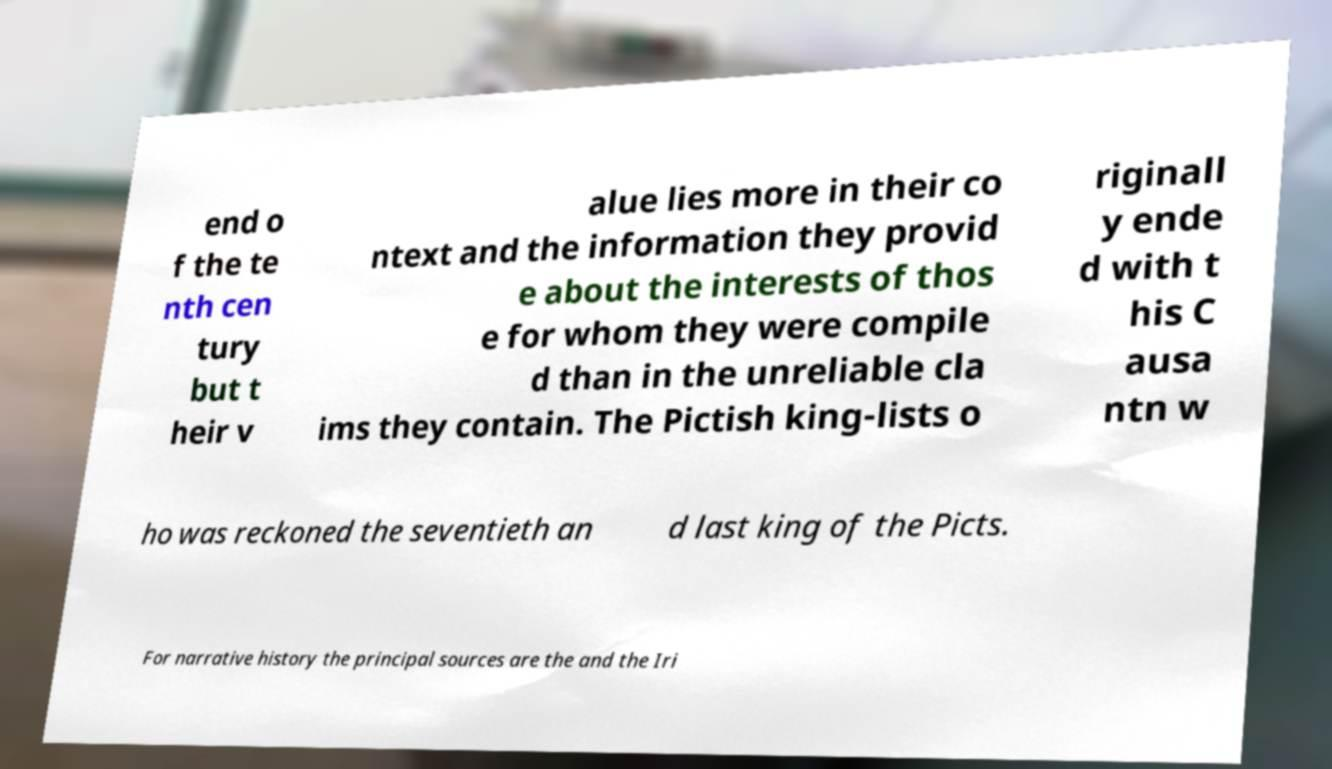Please read and relay the text visible in this image. What does it say? end o f the te nth cen tury but t heir v alue lies more in their co ntext and the information they provid e about the interests of thos e for whom they were compile d than in the unreliable cla ims they contain. The Pictish king-lists o riginall y ende d with t his C ausa ntn w ho was reckoned the seventieth an d last king of the Picts. For narrative history the principal sources are the and the Iri 